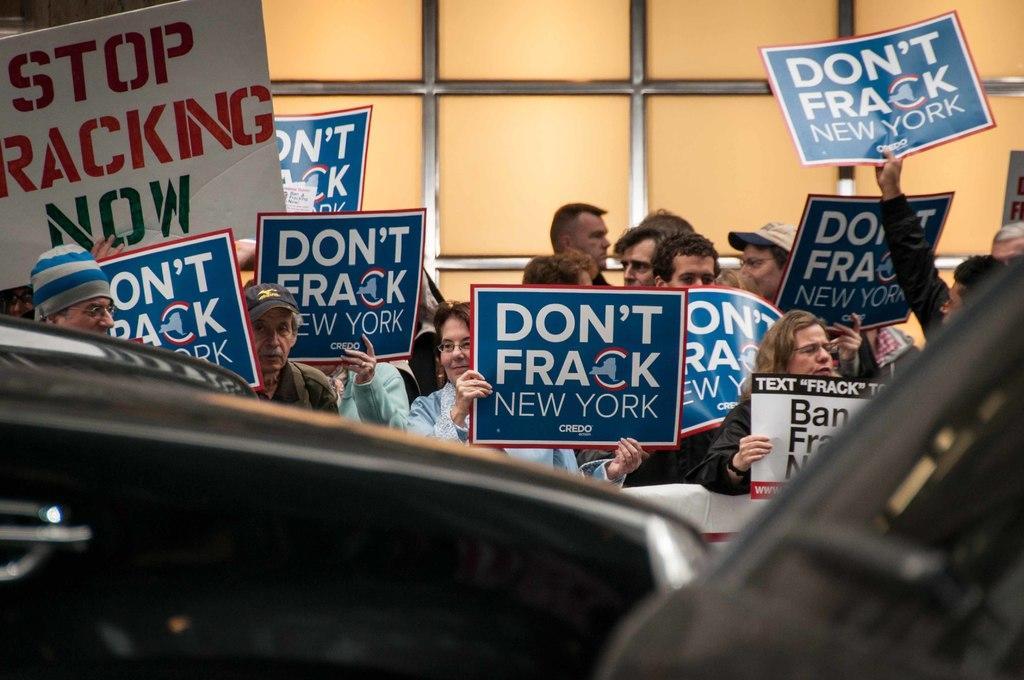How would you summarize this image in a sentence or two? In this image I can see group of people standing and they are holding few posters and I can also see the board in white color. In front I can see the vehicle. 